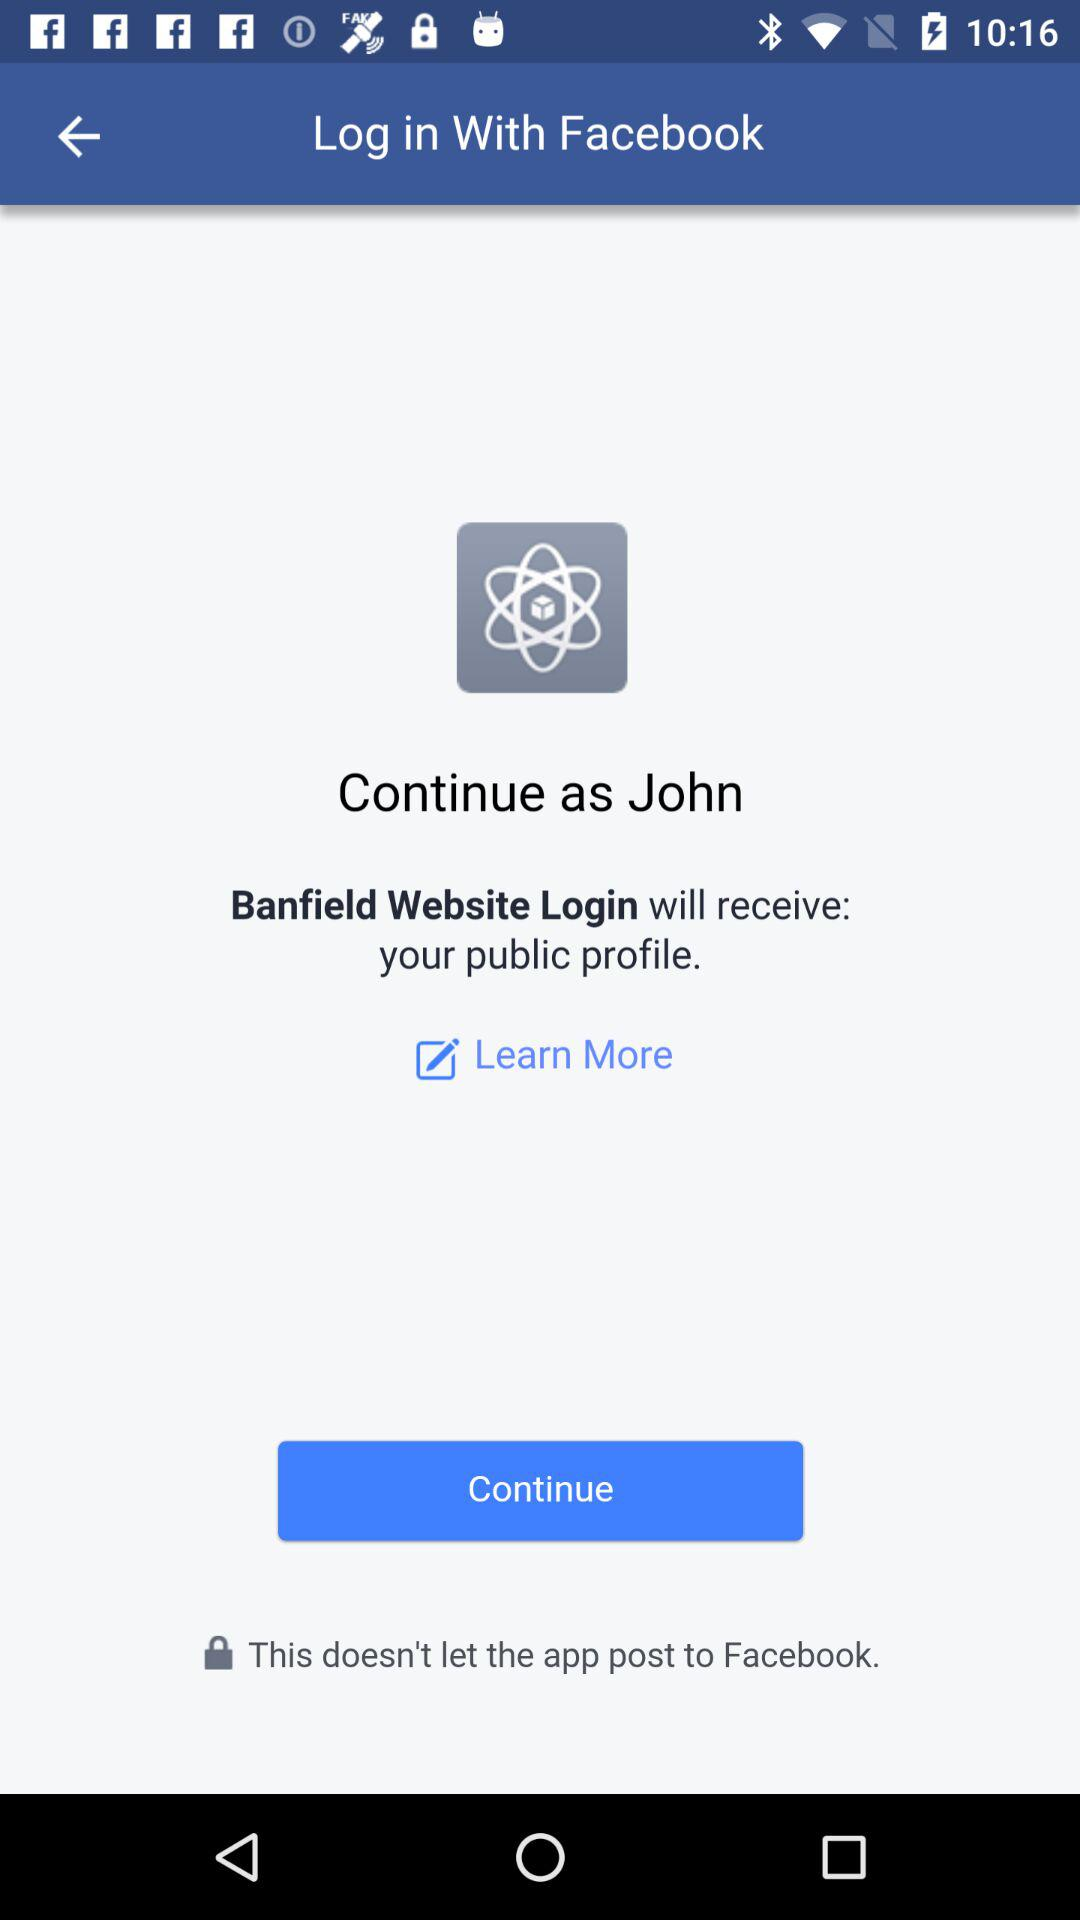Which application can be used to log in? The application "Facebook" can be used to log in. 